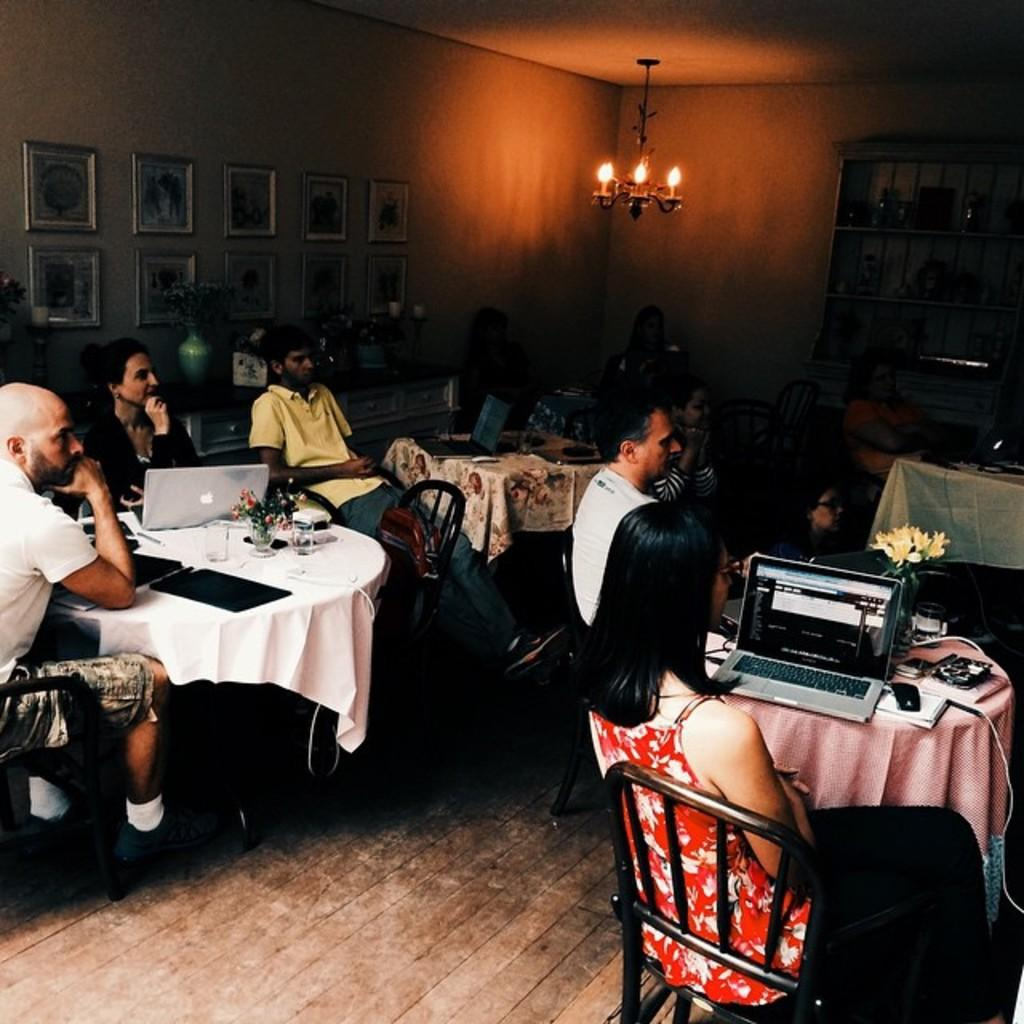What are the people in the image doing? The people in the image are sitting on chairs. What objects are on the tables in the image? There are laptops on tables in the image. What can be seen on the wall in the background of the image? There are frames on the wall in the background of the image. What type of nut is being used to power the laptops in the image? There are no nuts present in the image, and laptops are powered by electricity, not nuts. 